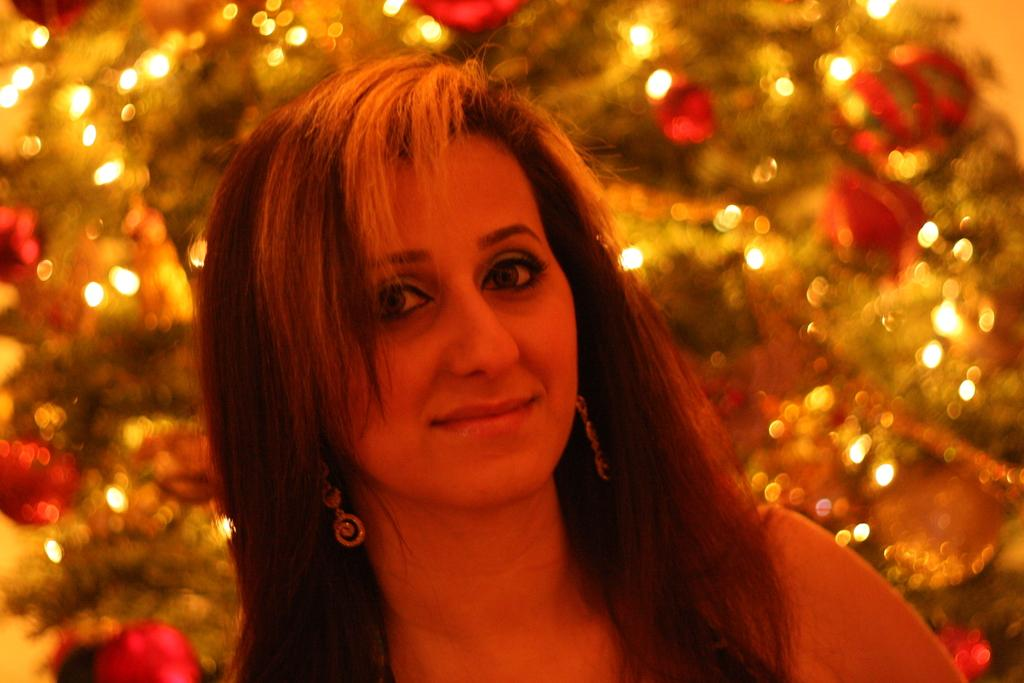Who is present in the image? There is a lady in the image. What can be seen in the background of the image? There are lights and objects in the background of the image. What number is the lady counting in the image? There is no indication in the image that the lady is counting or performing any specific action. 